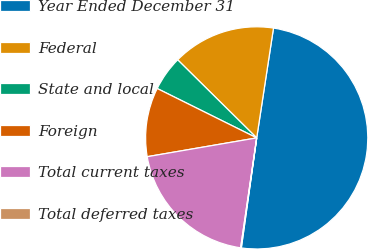Convert chart. <chart><loc_0><loc_0><loc_500><loc_500><pie_chart><fcel>Year Ended December 31<fcel>Federal<fcel>State and local<fcel>Foreign<fcel>Total current taxes<fcel>Total deferred taxes<nl><fcel>49.79%<fcel>15.01%<fcel>5.07%<fcel>10.04%<fcel>19.98%<fcel>0.1%<nl></chart> 